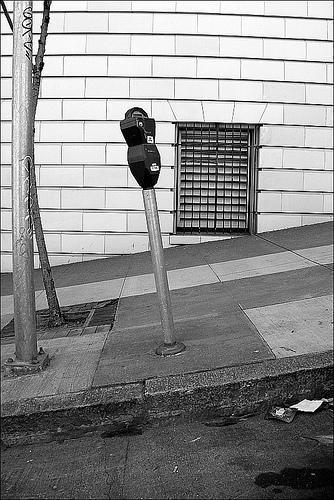How many trees are in this picture?
Give a very brief answer. 1. How many people is this man playing against?
Give a very brief answer. 0. 